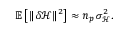Convert formula to latex. <formula><loc_0><loc_0><loc_500><loc_500>\mathbb { E } \left [ \| \delta \mathcal { H } \| ^ { 2 } \right ] \approx n _ { p } \, \sigma _ { \mathcal { H } } ^ { 2 } .</formula> 